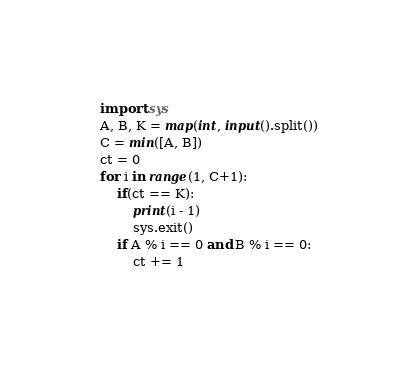<code> <loc_0><loc_0><loc_500><loc_500><_Python_>import sys
A, B, K = map(int, input().split())
C = min([A, B])
ct = 0
for i in range(1, C+1):
    if(ct == K):
        print(i - 1)
        sys.exit()
    if A % i == 0 and B % i == 0:
        ct += 1</code> 